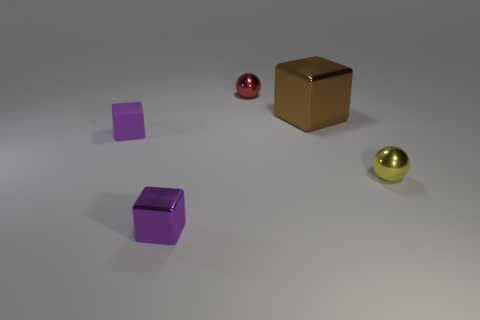The purple rubber cube has what size?
Keep it short and to the point. Small. What shape is the small shiny thing that is left of the large brown metallic thing and in front of the red thing?
Ensure brevity in your answer.  Cube. What color is the other big thing that is the same shape as the purple rubber thing?
Your answer should be very brief. Brown. How many things are either small things behind the yellow sphere or purple cubes that are in front of the small yellow shiny thing?
Your answer should be compact. 3. What is the shape of the tiny yellow metal object?
Make the answer very short. Sphere. The other object that is the same color as the matte object is what shape?
Ensure brevity in your answer.  Cube. How many big objects are made of the same material as the brown block?
Ensure brevity in your answer.  0. What color is the matte object?
Your answer should be compact. Purple. What color is the other metallic ball that is the same size as the red ball?
Make the answer very short. Yellow. Are there any tiny matte objects of the same color as the small shiny cube?
Offer a terse response. Yes. 